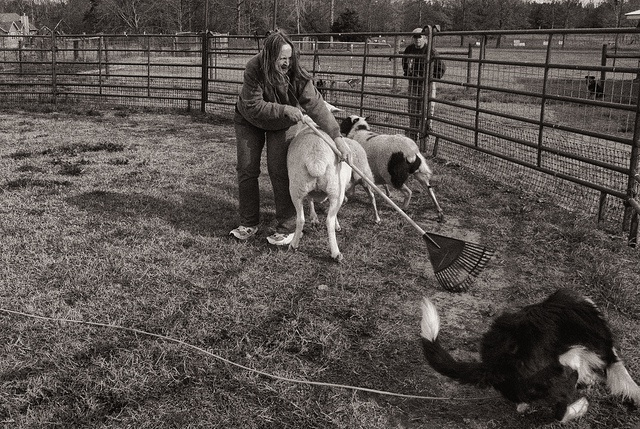Describe the objects in this image and their specific colors. I can see dog in gray, black, darkgray, and lightgray tones, people in gray, black, and darkgray tones, sheep in gray, darkgray, lightgray, and black tones, sheep in gray, black, darkgray, and lightgray tones, and people in gray, black, and darkgray tones in this image. 